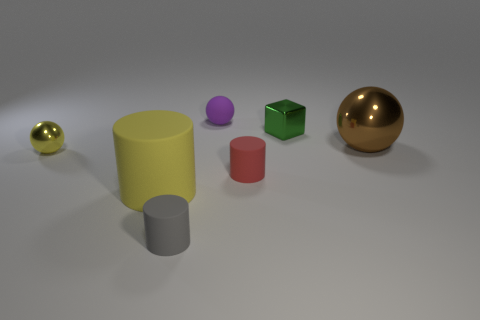Add 2 yellow metal balls. How many objects exist? 9 Subtract all cubes. How many objects are left? 6 Add 2 big green metal cubes. How many big green metal cubes exist? 2 Subtract 0 yellow cubes. How many objects are left? 7 Subtract all red cylinders. Subtract all big green things. How many objects are left? 6 Add 2 green shiny objects. How many green shiny objects are left? 3 